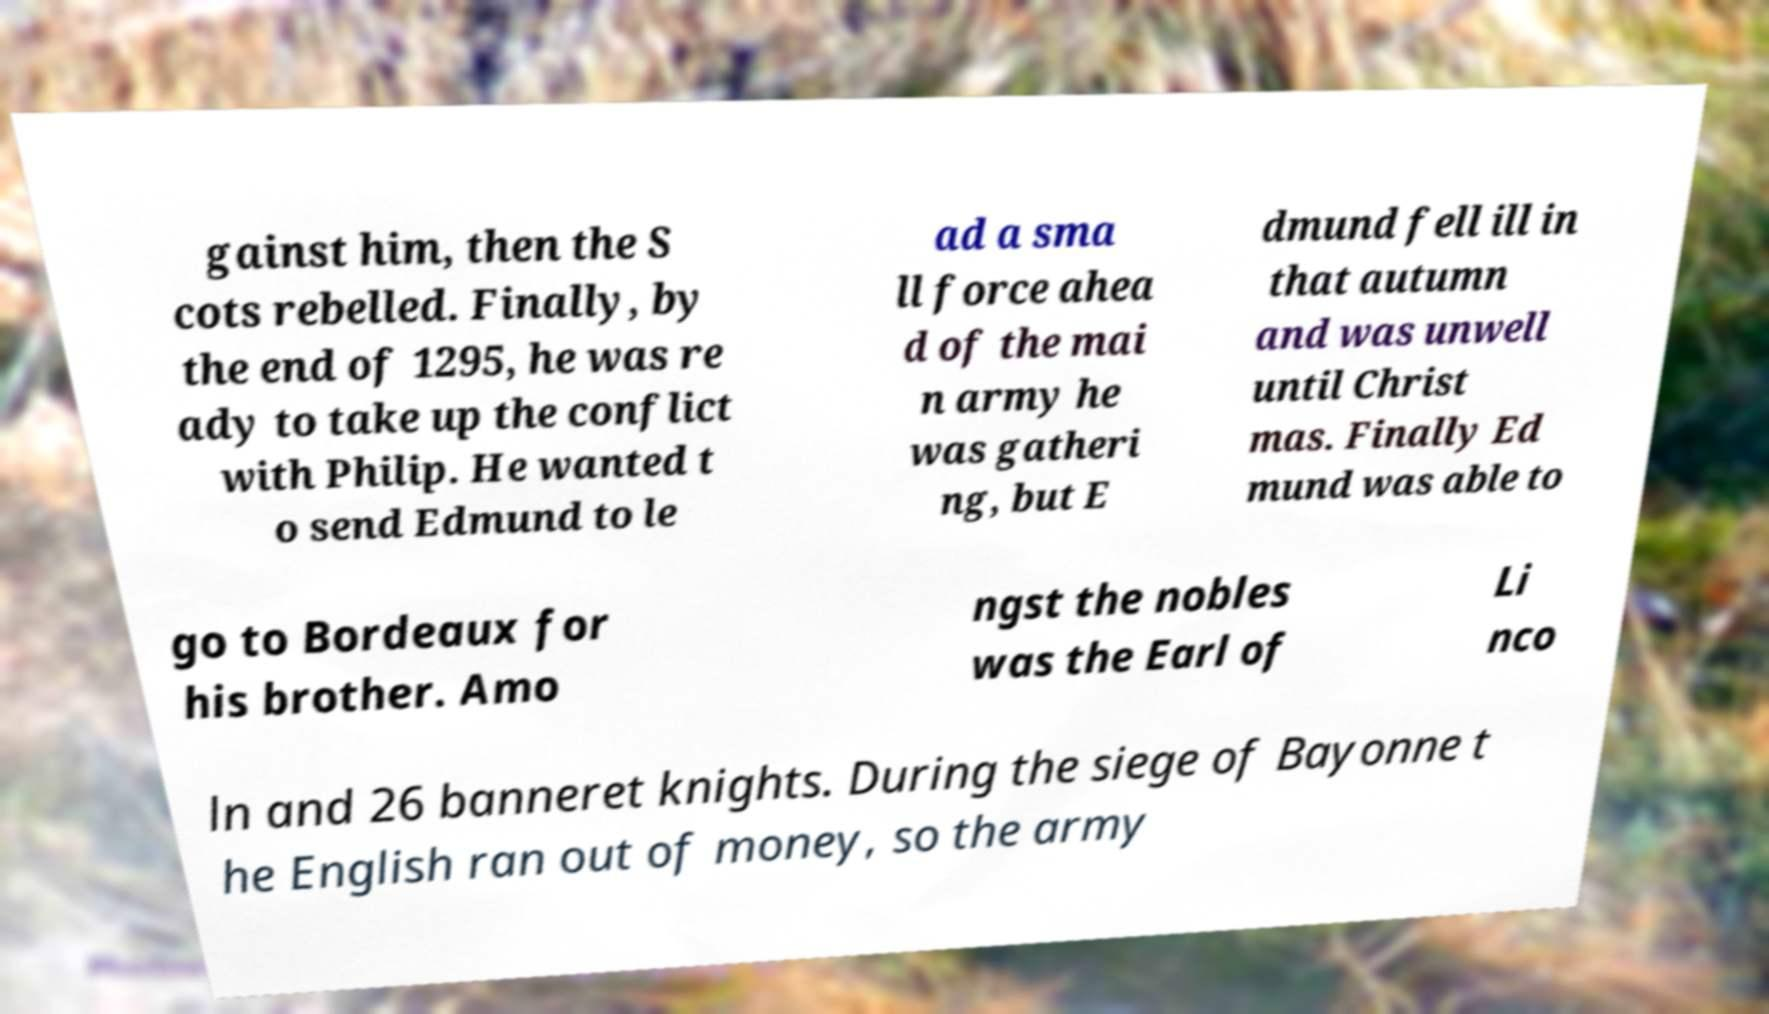There's text embedded in this image that I need extracted. Can you transcribe it verbatim? gainst him, then the S cots rebelled. Finally, by the end of 1295, he was re ady to take up the conflict with Philip. He wanted t o send Edmund to le ad a sma ll force ahea d of the mai n army he was gatheri ng, but E dmund fell ill in that autumn and was unwell until Christ mas. Finally Ed mund was able to go to Bordeaux for his brother. Amo ngst the nobles was the Earl of Li nco ln and 26 banneret knights. During the siege of Bayonne t he English ran out of money, so the army 